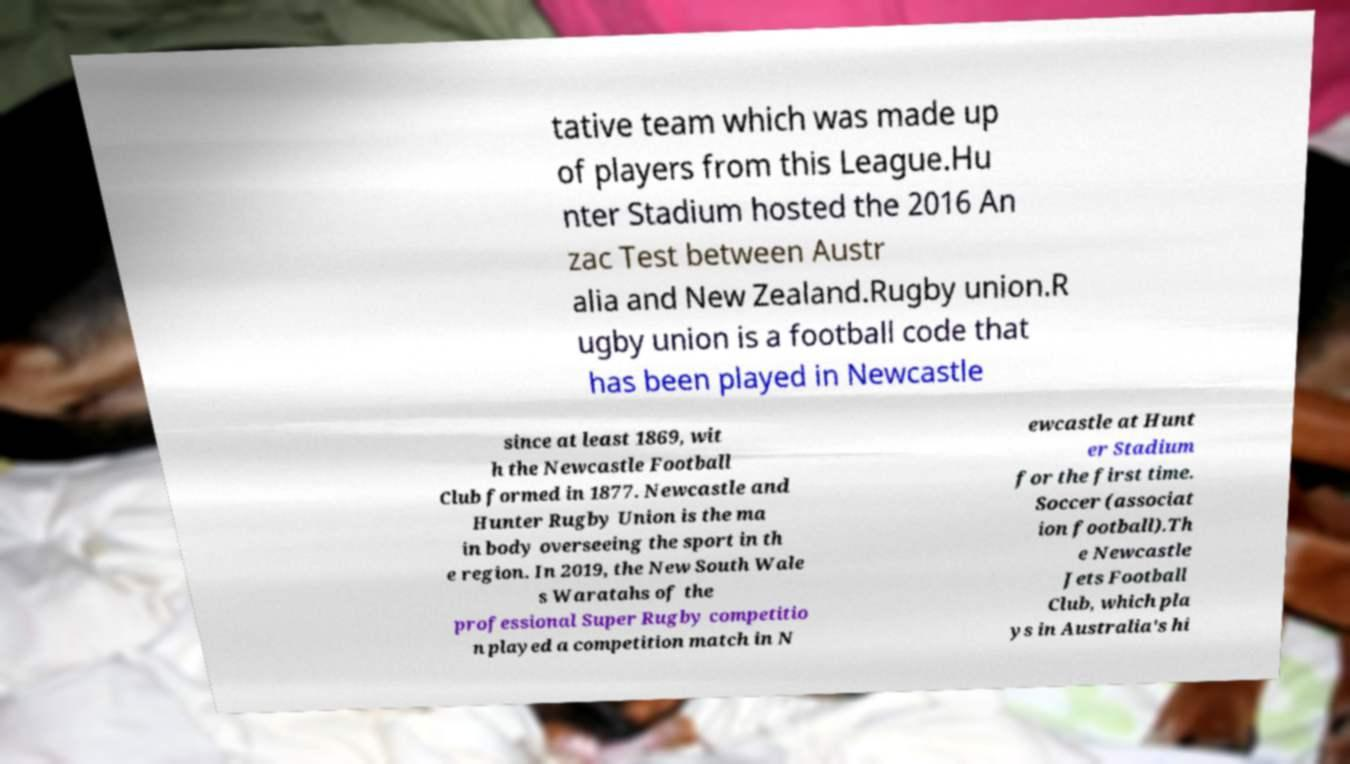Can you accurately transcribe the text from the provided image for me? tative team which was made up of players from this League.Hu nter Stadium hosted the 2016 An zac Test between Austr alia and New Zealand.Rugby union.R ugby union is a football code that has been played in Newcastle since at least 1869, wit h the Newcastle Football Club formed in 1877. Newcastle and Hunter Rugby Union is the ma in body overseeing the sport in th e region. In 2019, the New South Wale s Waratahs of the professional Super Rugby competitio n played a competition match in N ewcastle at Hunt er Stadium for the first time. Soccer (associat ion football).Th e Newcastle Jets Football Club, which pla ys in Australia's hi 